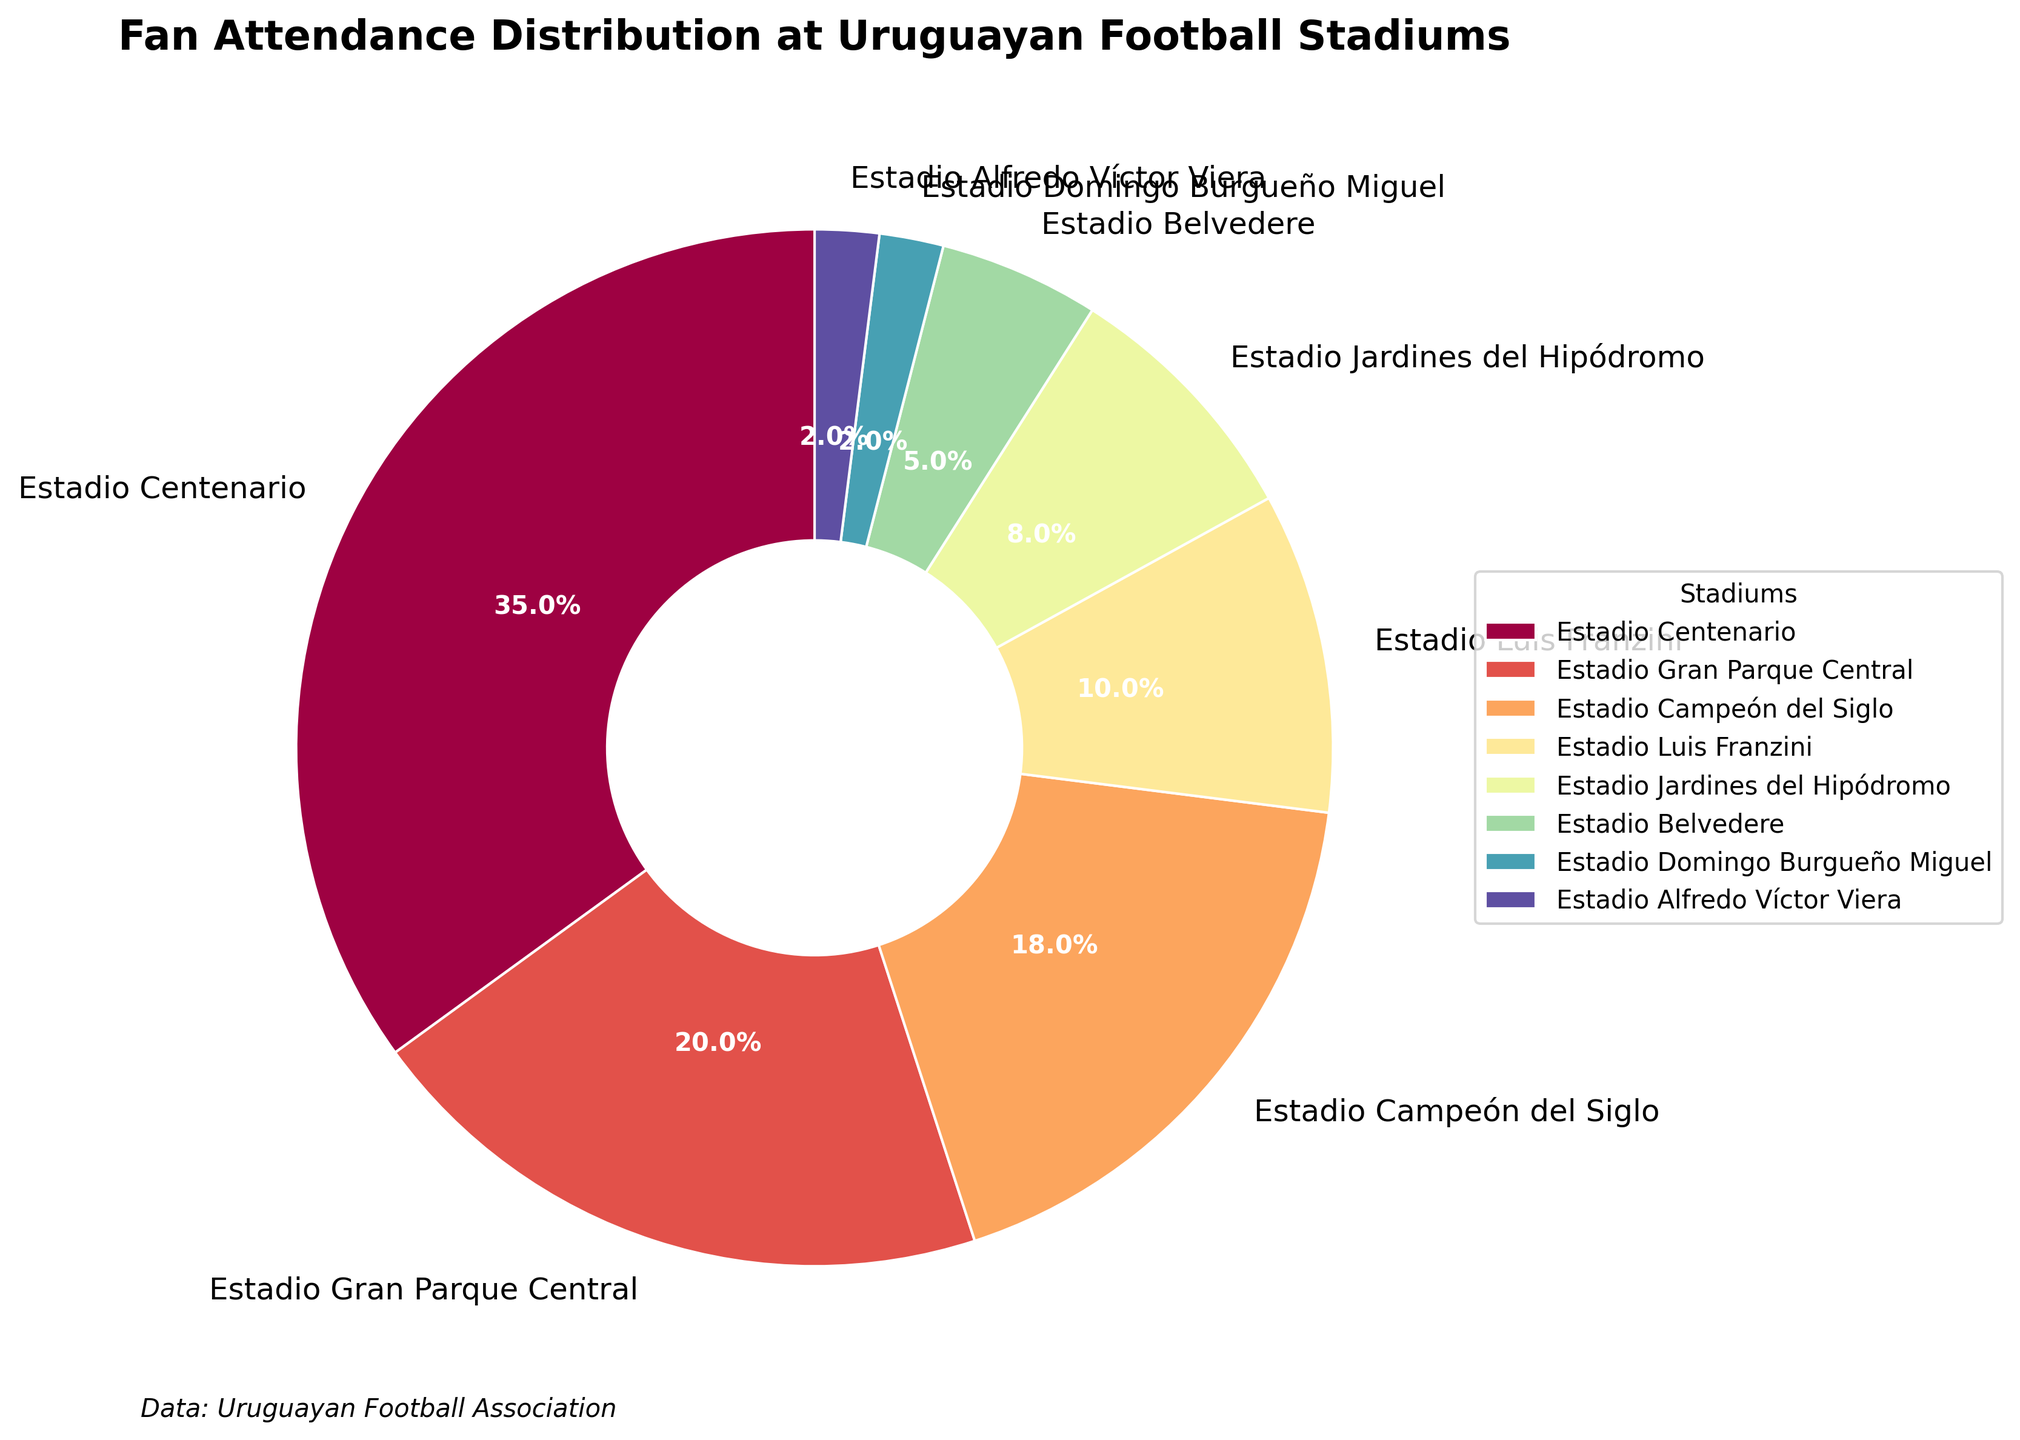Which stadium has the highest fan attendance percentage? The figure shows that Estadio Centenario has the largest segment in the pie chart, labeled with 35%.
Answer: Estadio Centenario What is the combined attendance percentage of Estadio Gran Parque Central and Estadio Campeón del Siglo? Estadio Gran Parque Central has an attendance of 20%, and Estadio Campeón del Siglo has 18%. Adding these two percentages gives 20% + 18% = 38%.
Answer: 38% Which stadium has the smallest fan attendance percentage, and what is that percentage? The smallest segment in the pie chart is that of Estadio Alfredo Víctor Viera, labeled with 2%.
Answer: Estadio Alfredo Víctor Viera, 2% How much higher is the attendance at Estadio Centenario compared to Estadio Jardines del Hipódromo? Estadio Centenario has 35% attendance, and Estadio Jardines del Hipódromo has 8%. Subtracting these values gives 35% - 8% = 27%.
Answer: 27% Which stadiums together contribute to more than 50% of the total fan attendance? Estadio Centenario, Estadio Gran Parque Central, and Estadio Campeón del Siglo have attendance percentages of 35%, 20%, and 18%, respectively. Adding these gives 35% + 20% + 18% = 73%, which is more than 50%.
Answer: Estadio Centenario, Estadio Gran Parque Central, Estadio Campeón del Siglo What is the percentage difference between the attendance at Estadio Belvedere and Estadio Luis Franzini? Estadio Belvedere has 5% attendance, and Estadio Luis Franzini has 10%. Subtracting these values gives 10% - 5% = 5%.
Answer: 5% What is the total fan attendance percentage of the three stadiums with the lowest attendance? Estadio Domingo Burgueño Miguel, Estadio Alfredo Víctor Viera, and Estadio Belvedere have attendance percentages of 2%, 2%, and 5%, respectively. Adding these gives 2% + 2% + 5% = 9%.
Answer: 9% Which stadiums have an attendance percentage less than 10%? The stadiums with less than 10% attendance are Estadio Luis Franzini (10%), Estadio Jardines del Hipódromo (8%), Estadio Belvedere (5%), Estadio Domingo Burgueño Miguel (2%), and Estadio Alfredo Víctor Viera (2%).
Answer: Estadio Jardines del Hipódromo, Estadio Belvedere, Estadio Domingo Burgueño Miguel, Estadio Alfredo Víctor Viera 